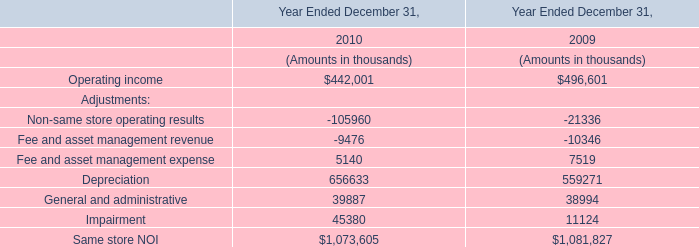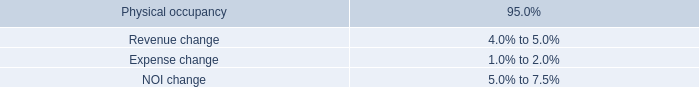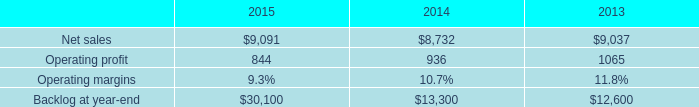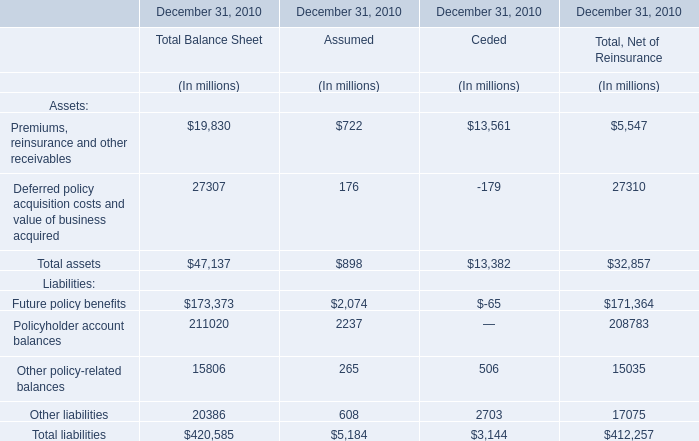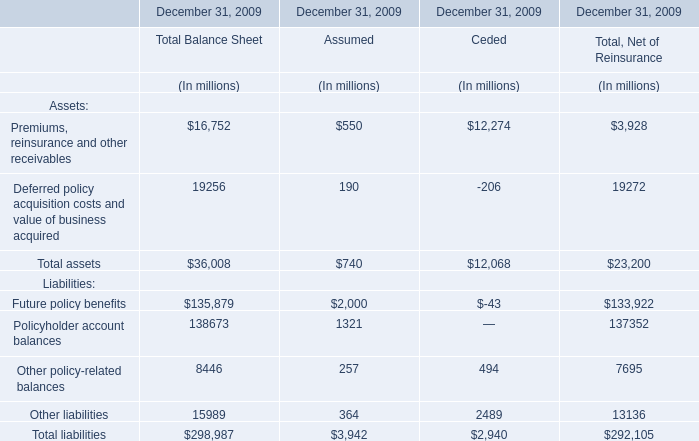What's the 20 % of total elements for Assumed in 2010? (in million) 
Computations: (5184 * 0.2)
Answer: 1036.8. 